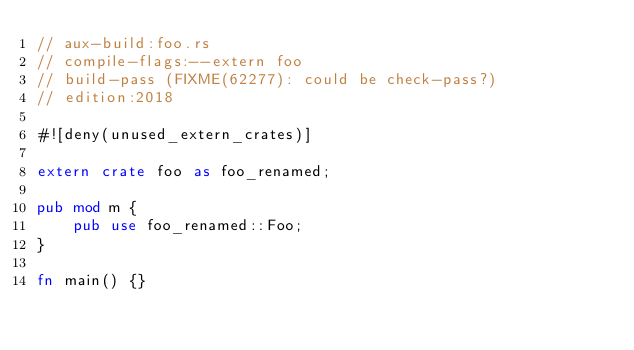<code> <loc_0><loc_0><loc_500><loc_500><_Rust_>// aux-build:foo.rs
// compile-flags:--extern foo
// build-pass (FIXME(62277): could be check-pass?)
// edition:2018

#![deny(unused_extern_crates)]

extern crate foo as foo_renamed;

pub mod m {
    pub use foo_renamed::Foo;
}

fn main() {}
</code> 